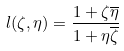<formula> <loc_0><loc_0><loc_500><loc_500>l ( \zeta , \eta ) = \frac { 1 + \zeta \overline { \eta } } { 1 + \eta \overline { \zeta } }</formula> 